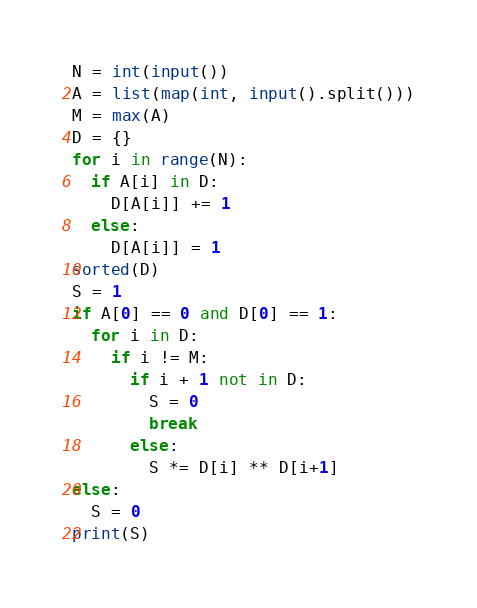<code> <loc_0><loc_0><loc_500><loc_500><_Python_>N = int(input())
A = list(map(int, input().split()))
M = max(A)
D = {}
for i in range(N):
  if A[i] in D:
    D[A[i]] += 1
  else:
    D[A[i]] = 1
sorted(D)
S = 1
if A[0] == 0 and D[0] == 1:
  for i in D:
    if i != M:
      if i + 1 not in D:
        S = 0
        break
      else:
        S *= D[i] ** D[i+1]
else:
  S = 0
print(S)
</code> 